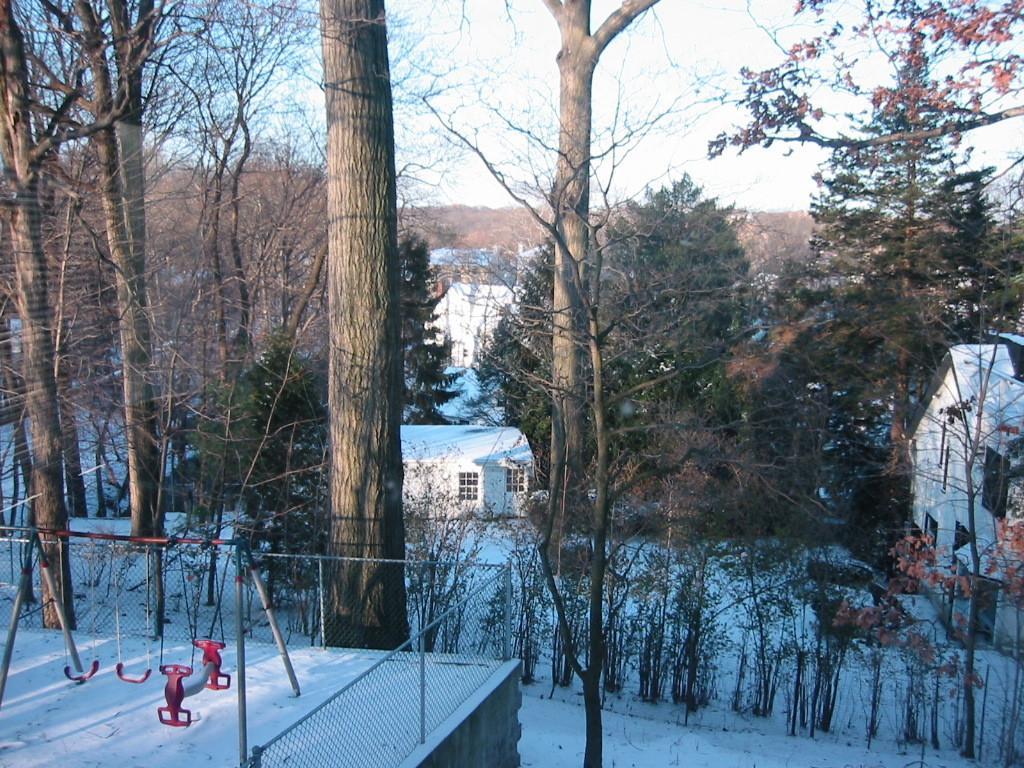Could you give a brief overview of what you see in this image? In this image we can see few playground swings inside a closed metal mesh fencing, in this image there are trees, buildings and on the surface there is snow. 